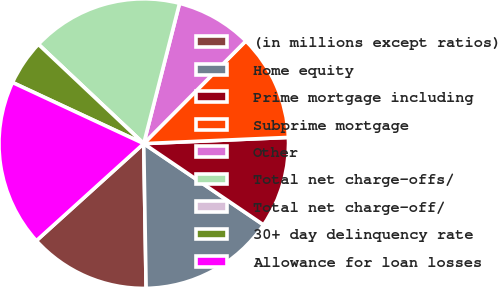<chart> <loc_0><loc_0><loc_500><loc_500><pie_chart><fcel>(in millions except ratios)<fcel>Home equity<fcel>Prime mortgage including<fcel>Subprime mortgage<fcel>Other<fcel>Total net charge-offs/<fcel>Total net charge-off/<fcel>30+ day delinquency rate<fcel>Allowance for loan losses<nl><fcel>13.56%<fcel>15.25%<fcel>10.17%<fcel>11.86%<fcel>8.48%<fcel>16.95%<fcel>0.0%<fcel>5.09%<fcel>18.64%<nl></chart> 